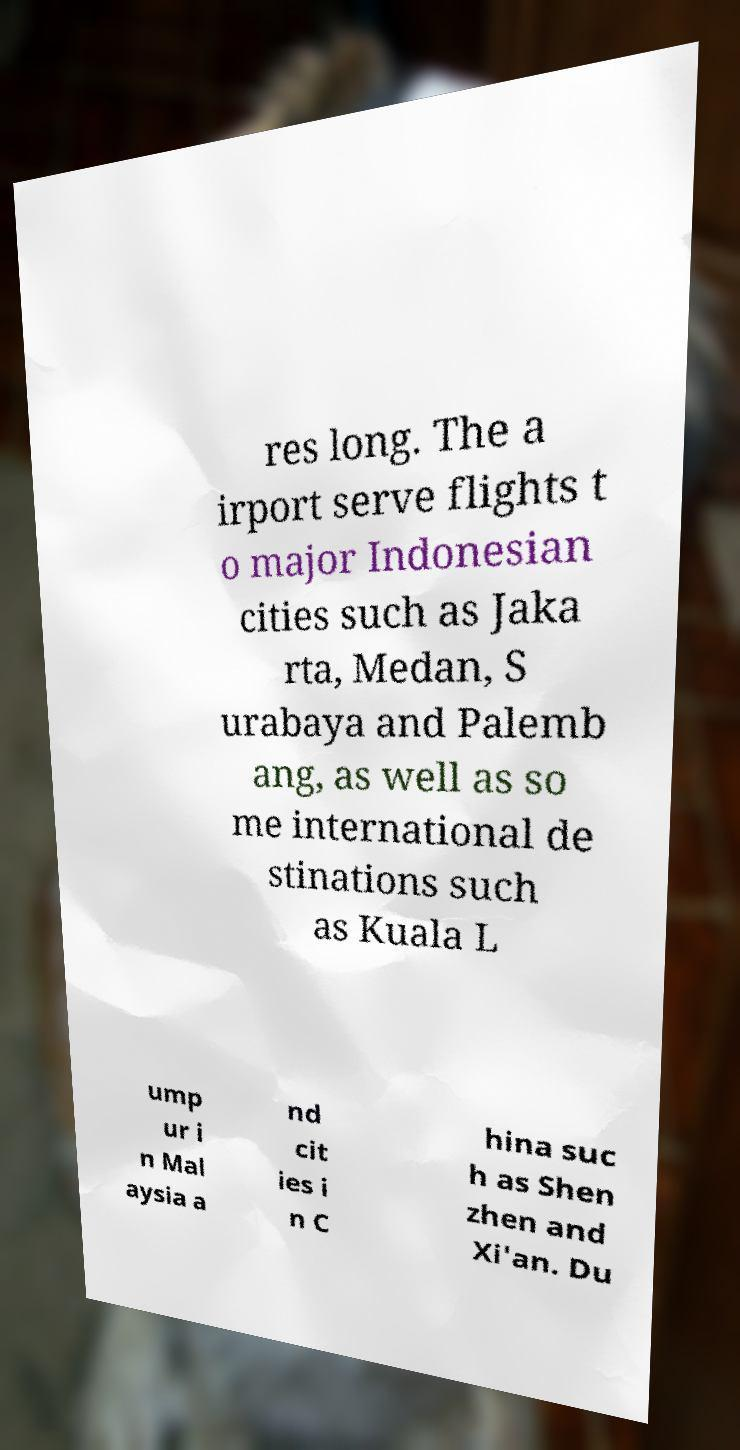Can you read and provide the text displayed in the image?This photo seems to have some interesting text. Can you extract and type it out for me? res long. The a irport serve flights t o major Indonesian cities such as Jaka rta, Medan, S urabaya and Palemb ang, as well as so me international de stinations such as Kuala L ump ur i n Mal aysia a nd cit ies i n C hina suc h as Shen zhen and Xi'an. Du 